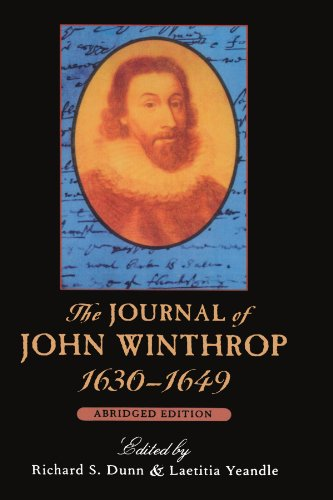What is the title of this book? The title of the book is 'The Journal of John Winthrop, 1630-1649: Abridged Edition (The John Harvard Library)', which chronicles the significant events of his life and his role in the founding of the Massachusetts Bay Colony. 